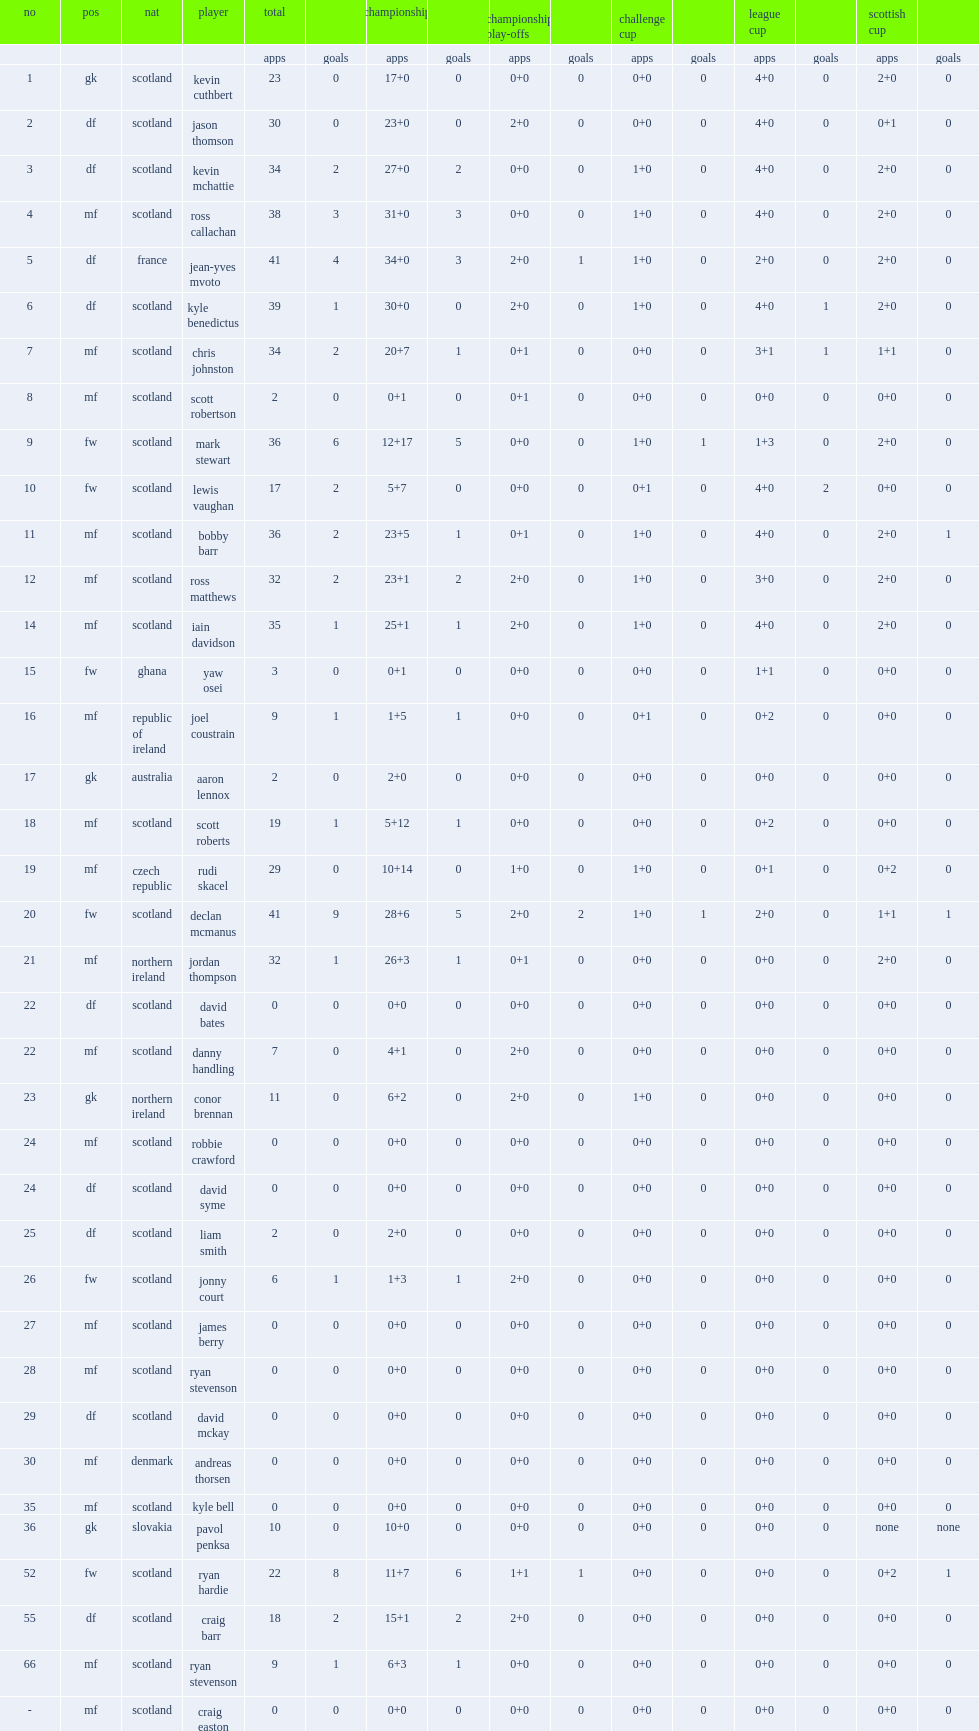List the matches that raith rovers compete in. Challenge cup league cup scottish cup. 